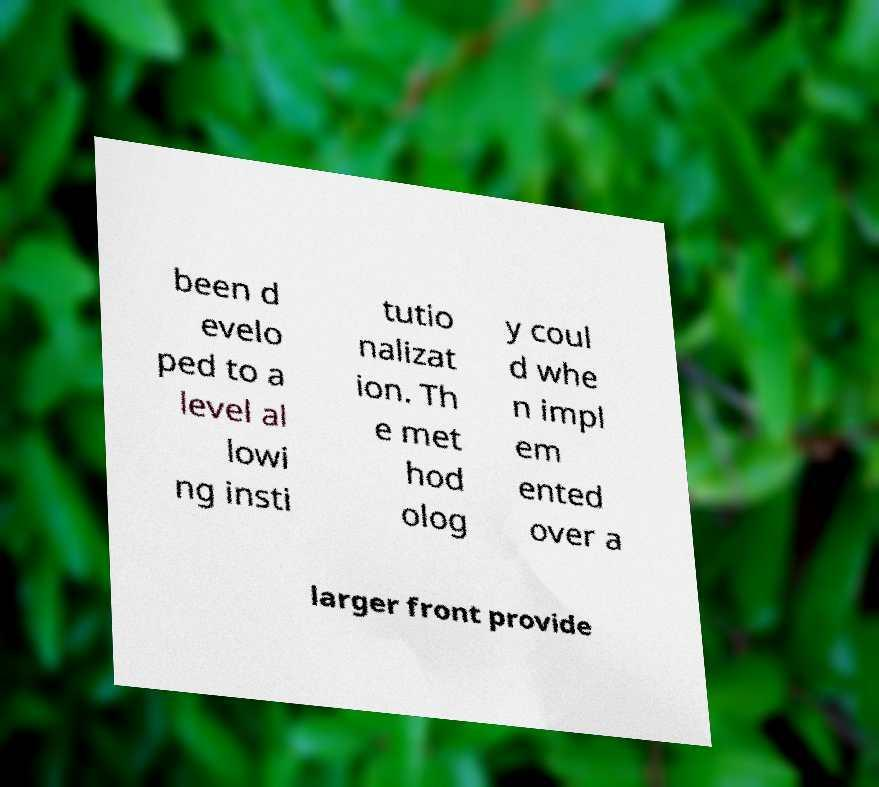Please read and relay the text visible in this image. What does it say? been d evelo ped to a level al lowi ng insti tutio nalizat ion. Th e met hod olog y coul d whe n impl em ented over a larger front provide 